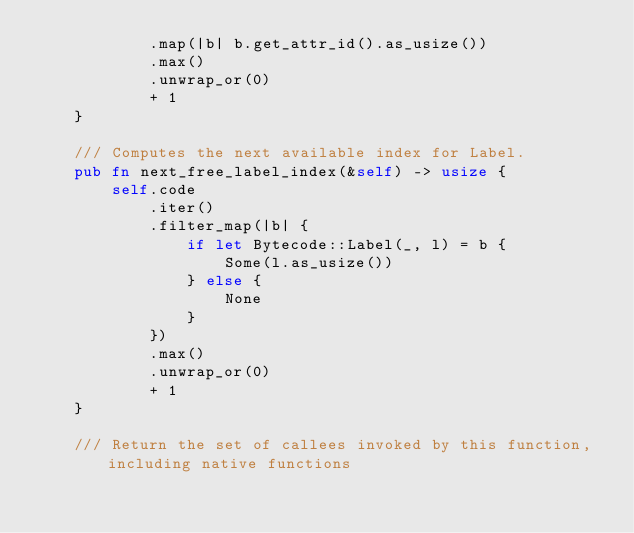Convert code to text. <code><loc_0><loc_0><loc_500><loc_500><_Rust_>            .map(|b| b.get_attr_id().as_usize())
            .max()
            .unwrap_or(0)
            + 1
    }

    /// Computes the next available index for Label.
    pub fn next_free_label_index(&self) -> usize {
        self.code
            .iter()
            .filter_map(|b| {
                if let Bytecode::Label(_, l) = b {
                    Some(l.as_usize())
                } else {
                    None
                }
            })
            .max()
            .unwrap_or(0)
            + 1
    }

    /// Return the set of callees invoked by this function, including native functions</code> 